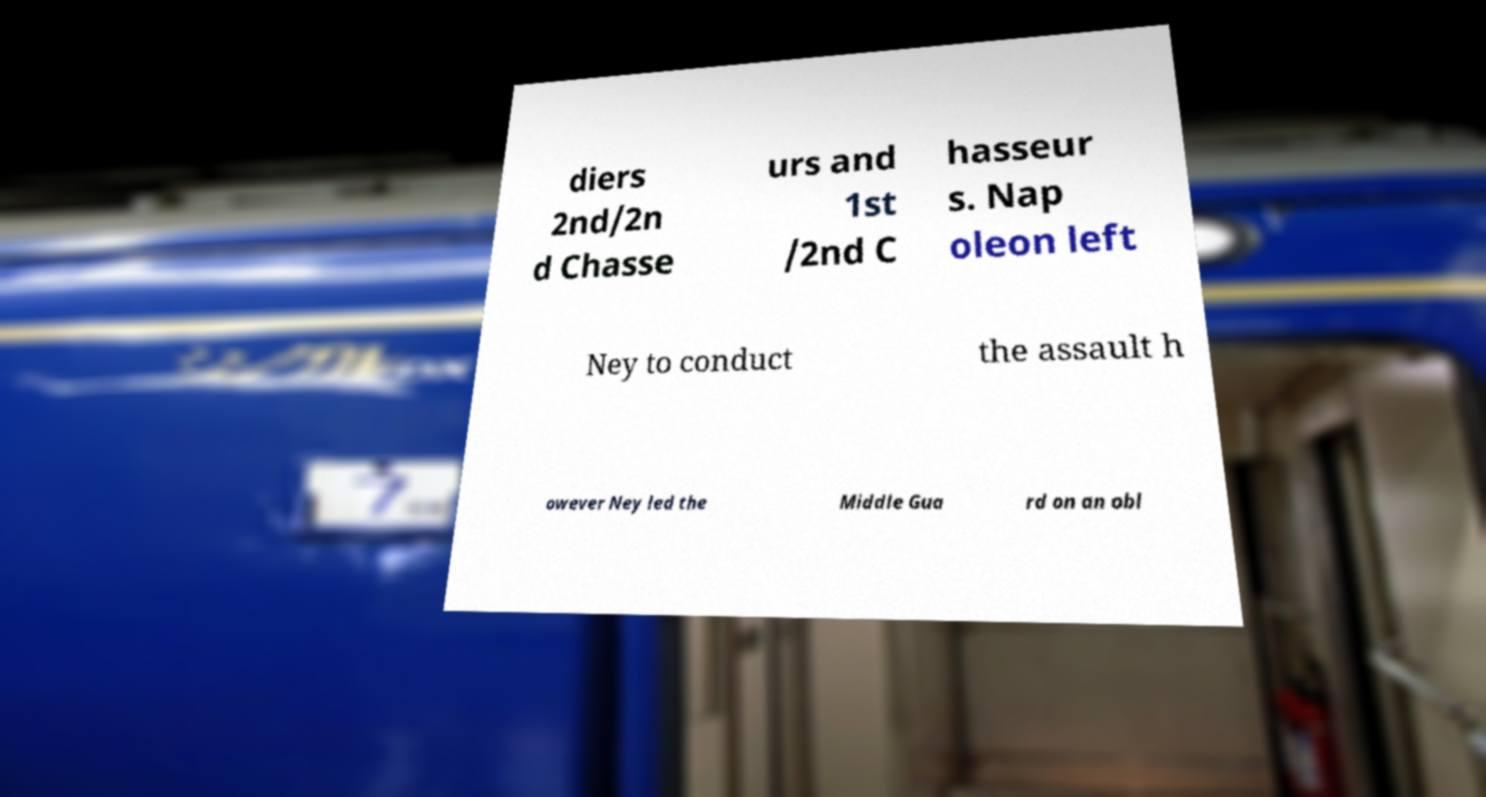Can you accurately transcribe the text from the provided image for me? diers 2nd/2n d Chasse urs and 1st /2nd C hasseur s. Nap oleon left Ney to conduct the assault h owever Ney led the Middle Gua rd on an obl 